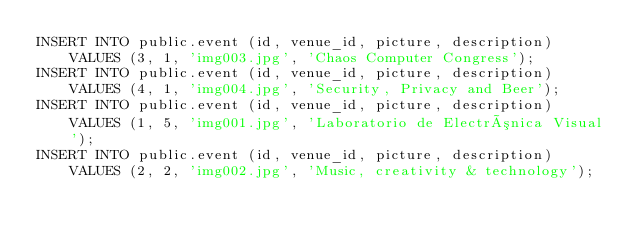Convert code to text. <code><loc_0><loc_0><loc_500><loc_500><_SQL_>INSERT INTO public.event (id, venue_id, picture, description) VALUES (3, 1, 'img003.jpg', 'Chaos Computer Congress');
INSERT INTO public.event (id, venue_id, picture, description) VALUES (4, 1, 'img004.jpg', 'Security, Privacy and Beer');
INSERT INTO public.event (id, venue_id, picture, description) VALUES (1, 5, 'img001.jpg', 'Laboratorio de Electrónica Visual');
INSERT INTO public.event (id, venue_id, picture, description) VALUES (2, 2, 'img002.jpg', 'Music, creativity & technology');
</code> 